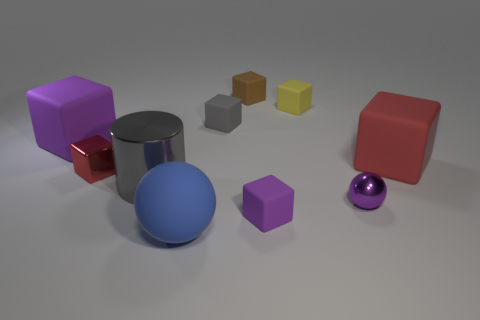Subtract all small gray cubes. How many cubes are left? 6 Subtract all red blocks. How many blocks are left? 5 Subtract 3 cubes. How many cubes are left? 4 Subtract all cyan blocks. Subtract all purple cylinders. How many blocks are left? 7 Subtract all cylinders. How many objects are left? 9 Add 1 small red things. How many small red things are left? 2 Add 4 large yellow shiny blocks. How many large yellow shiny blocks exist? 4 Subtract 0 blue cubes. How many objects are left? 10 Subtract all big metal spheres. Subtract all brown rubber cubes. How many objects are left? 9 